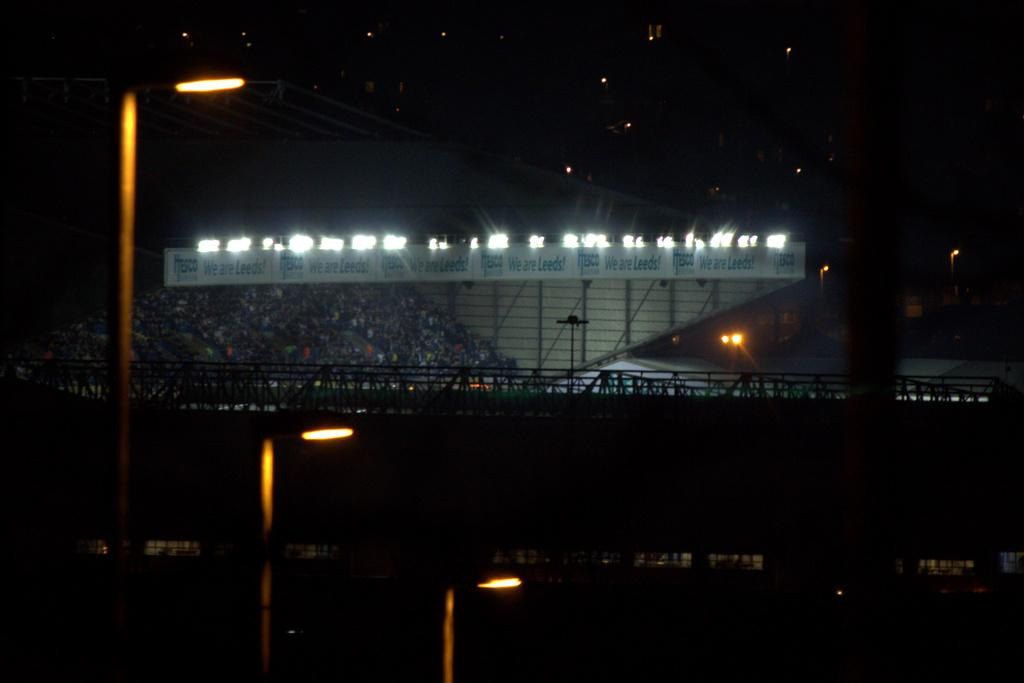What type of structures are present in the image with lights on them? There are poles with lights in the image. What type of advertisement or information might be displayed on the hoarding in the image? The content of the hoarding cannot be determined from the image, but it is a structure for displaying advertisements or information. What type of surface can be used for transportation in the image? There are roads in the image, which are surfaces for transportation. What is the general appearance of the background in the image? The background of the image has a dark view. Can you see any deer or beasts interacting with the poles in the image? There are no deer or beasts present in the image; it features poles with lights, a hoarding, roads, and a dark background. 